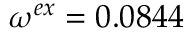Convert formula to latex. <formula><loc_0><loc_0><loc_500><loc_500>\omega ^ { e x } = 0 . 0 8 4 4</formula> 